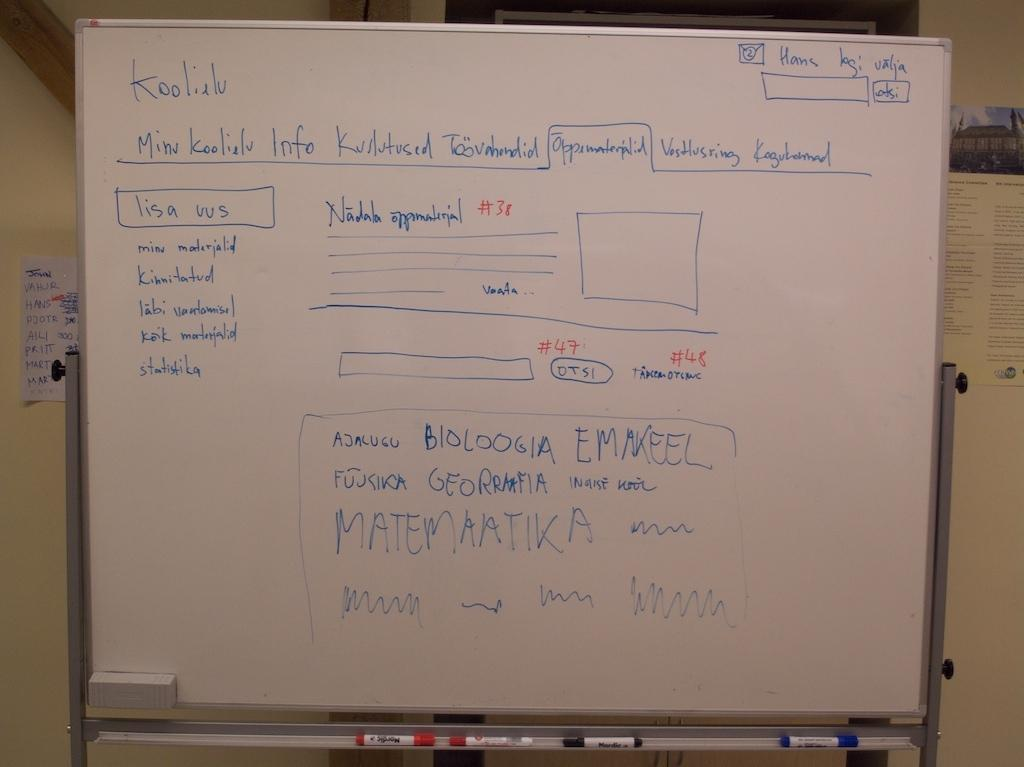<image>
Write a terse but informative summary of the picture. a white board with the term matemaatika on it 